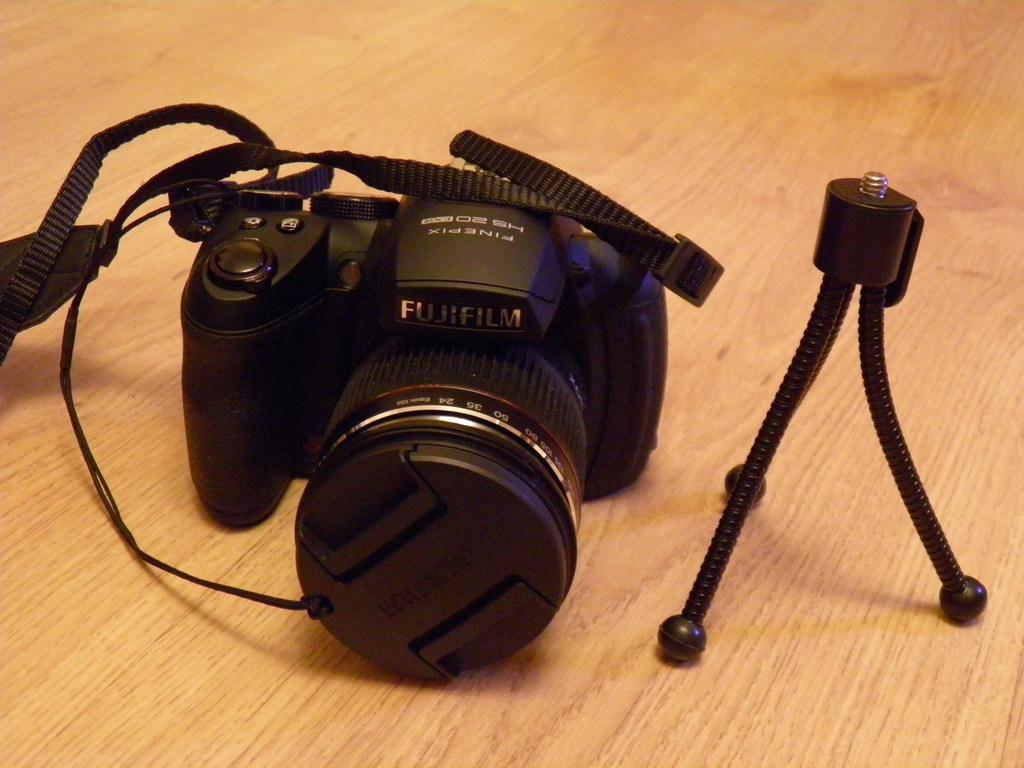What color is the stand in the image? The stand in the image is black. Where is the stand located in the image? The stand is on the right side of the image. What is the other main object in the image? There is a camera in the image. Where is the camera located in the image? The camera is on the left side of the image. What type of honey is being used to play music on the stand in the image? There is no honey or music present in the image; it features a black-colored stand and a camera. Is there a nose visible on the stand in the image? There is no nose present on the stand or anywhere else in the image. 